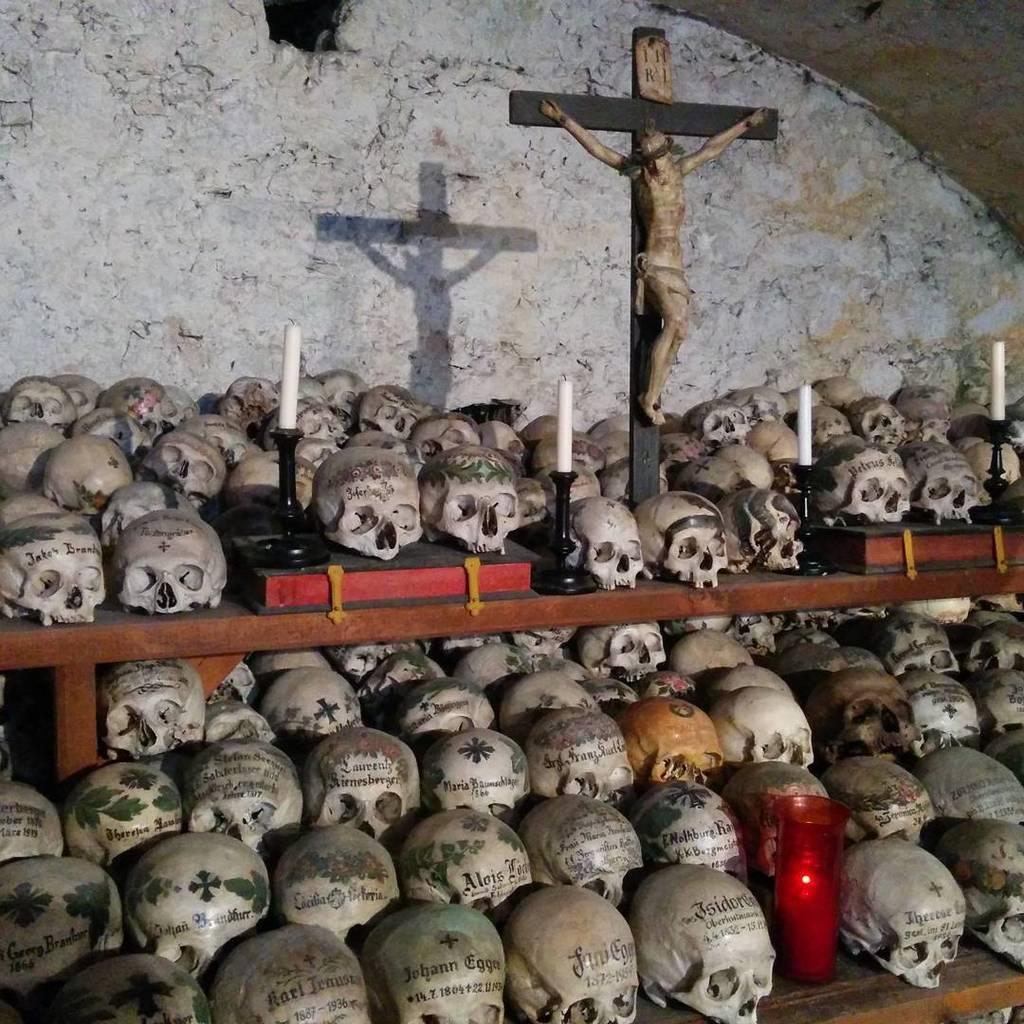Describe this image in one or two sentences. In this picture we can see a few skulls and a book on the shelves. Some text is visible on these skulls. We can see a few candles on the stands. There is a candle visible in an object. There is a person visible on a cross sign. We can see the shadow of the cross sign and a person on the wall. 